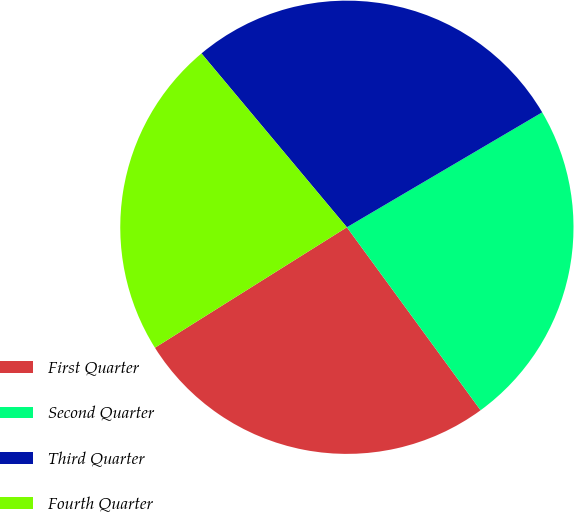<chart> <loc_0><loc_0><loc_500><loc_500><pie_chart><fcel>First Quarter<fcel>Second Quarter<fcel>Third Quarter<fcel>Fourth Quarter<nl><fcel>26.12%<fcel>23.42%<fcel>27.62%<fcel>22.83%<nl></chart> 